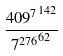Convert formula to latex. <formula><loc_0><loc_0><loc_500><loc_500>\frac { { 4 0 9 ^ { 7 } } ^ { 1 4 2 } } { { 7 ^ { 2 7 6 } } ^ { 6 2 } }</formula> 